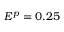<formula> <loc_0><loc_0><loc_500><loc_500>E ^ { p } = 0 . 2 5</formula> 